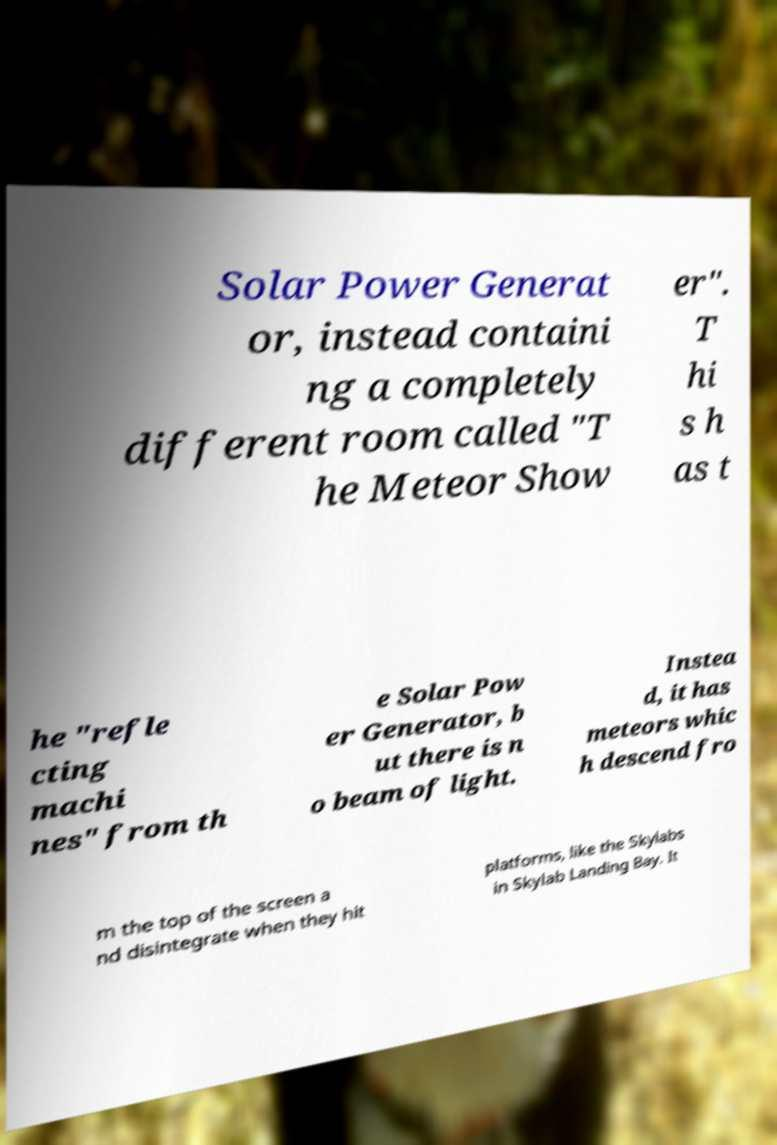I need the written content from this picture converted into text. Can you do that? Solar Power Generat or, instead containi ng a completely different room called "T he Meteor Show er". T hi s h as t he "refle cting machi nes" from th e Solar Pow er Generator, b ut there is n o beam of light. Instea d, it has meteors whic h descend fro m the top of the screen a nd disintegrate when they hit platforms, like the Skylabs in Skylab Landing Bay. It 